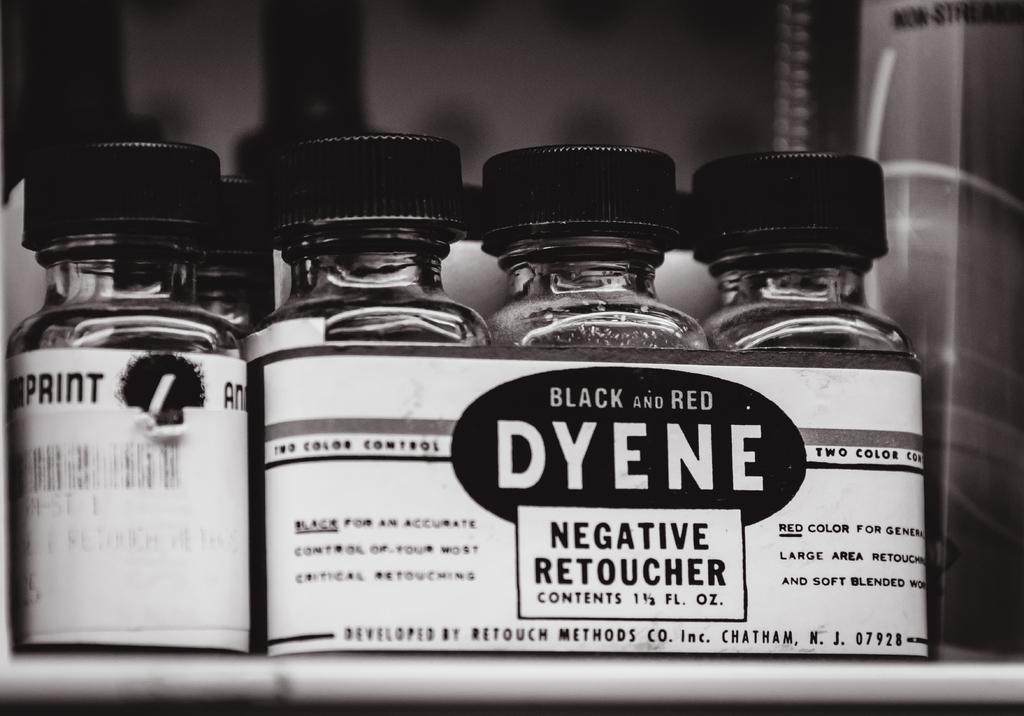<image>
Share a concise interpretation of the image provided. Bottles of Negative Retoucher with the name Dyene on the front. 